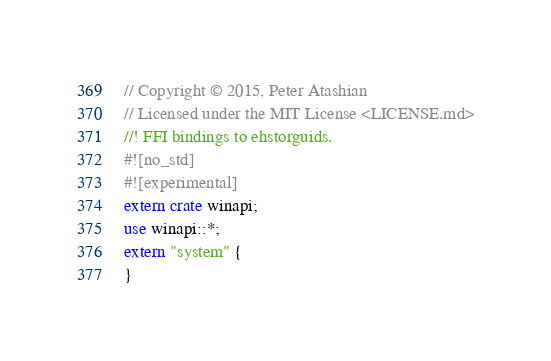<code> <loc_0><loc_0><loc_500><loc_500><_Rust_>// Copyright © 2015, Peter Atashian
// Licensed under the MIT License <LICENSE.md>
//! FFI bindings to ehstorguids.
#![no_std]
#![experimental]
extern crate winapi;
use winapi::*;
extern "system" {
}
</code> 